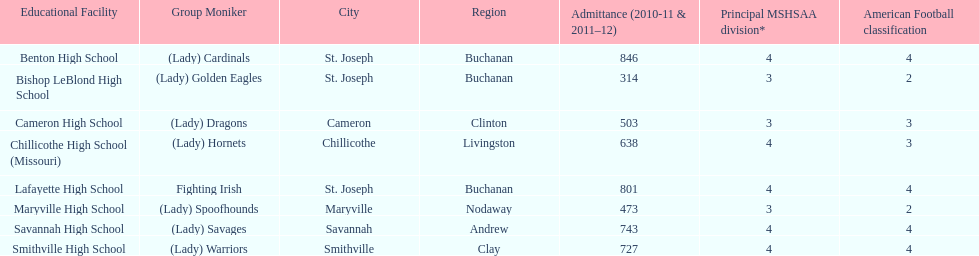Which schools are in the same town as bishop leblond? Benton High School, Lafayette High School. 